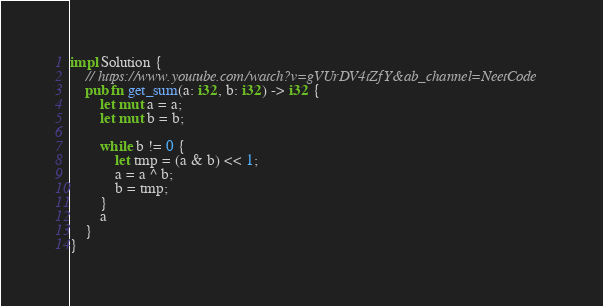Convert code to text. <code><loc_0><loc_0><loc_500><loc_500><_Rust_>impl Solution {
	// https://www.youtube.com/watch?v=gVUrDV4tZfY&ab_channel=NeetCode
    pub fn get_sum(a: i32, b: i32) -> i32 {
		let mut a = a;
		let mut b = b;

        while b != 0 {
			let tmp = (a & b) << 1;
			a = a ^ b;
			b = tmp;
		}
		a
    }
}
</code> 